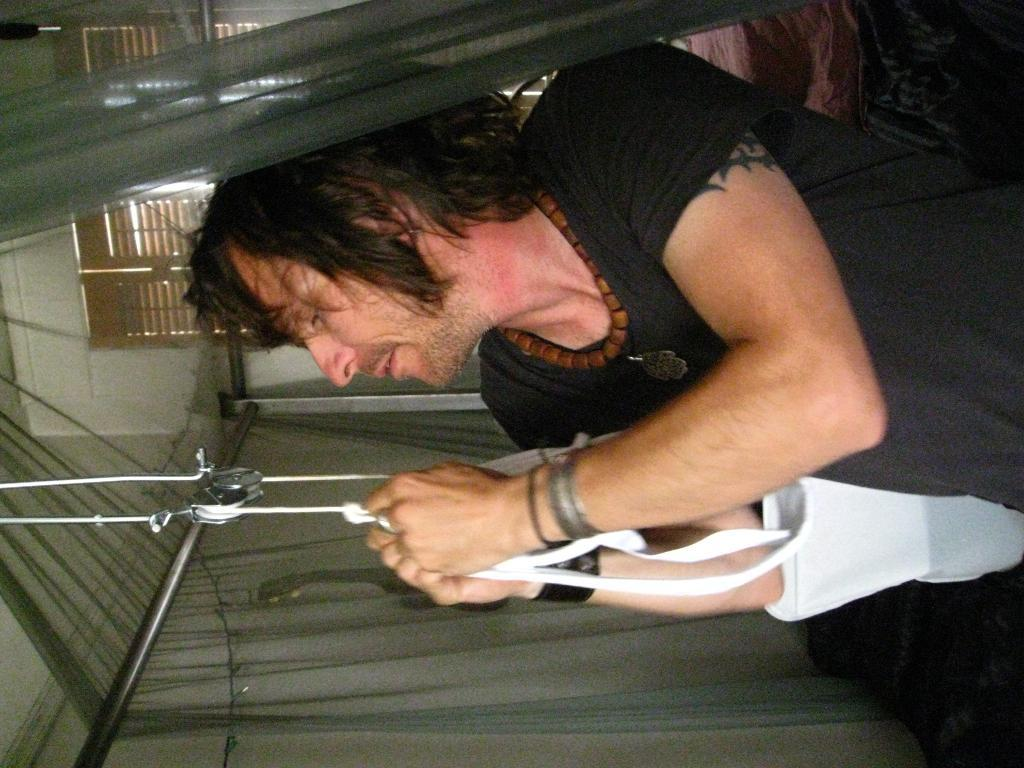What is the main subject of the image? There is a man in the image. What is the man doing in the image? The man is holding thread with his hands. What can be seen in the background of the image? There is a window, a wall, and rods in the background of the image. What type of stocking is the man wearing in the image? There is no mention of stockings in the image, so it cannot be determined if the man is wearing any. Can you tell me how many zebras are visible in the image? There are no zebras present in the image. 